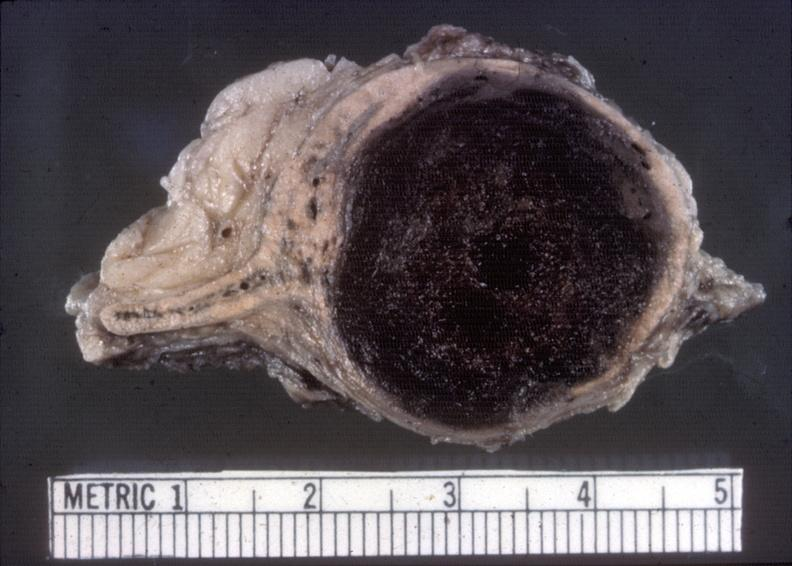what is present?
Answer the question using a single word or phrase. Endocrine 